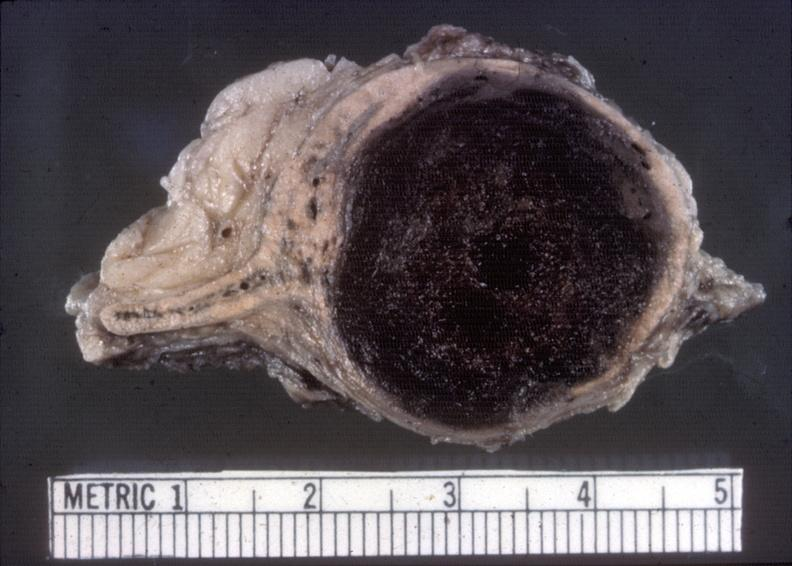what is present?
Answer the question using a single word or phrase. Endocrine 